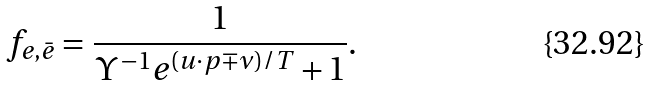<formula> <loc_0><loc_0><loc_500><loc_500>f _ { e , \bar { e } } = \frac { 1 } { \Upsilon ^ { - 1 } e ^ { ( u \cdot p \mp \nu ) / T } + 1 } .</formula> 